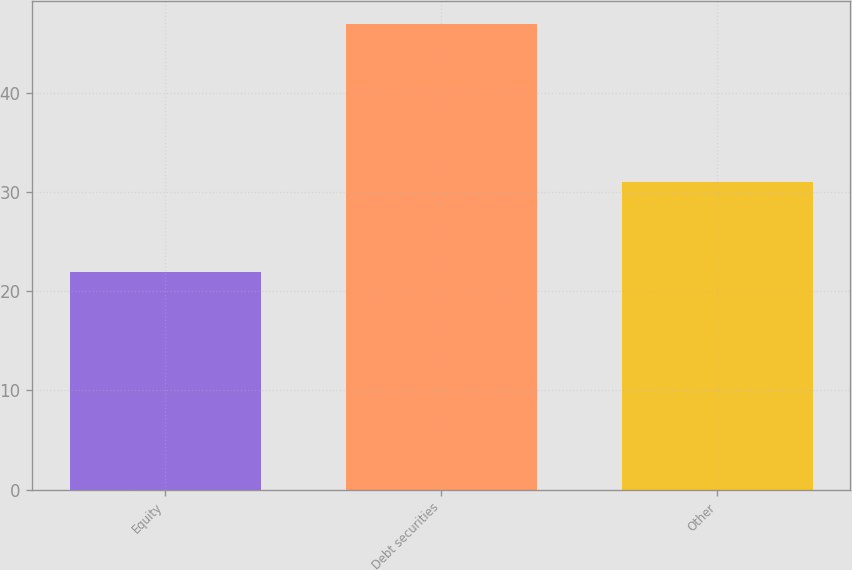<chart> <loc_0><loc_0><loc_500><loc_500><bar_chart><fcel>Equity<fcel>Debt securities<fcel>Other<nl><fcel>22<fcel>47<fcel>31<nl></chart> 